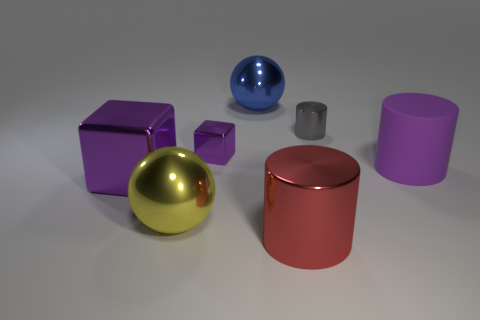Is the color of the large metallic cylinder the same as the rubber object?
Provide a short and direct response. No. There is a large yellow thing that is in front of the purple rubber thing; does it have the same shape as the small shiny object to the right of the big red thing?
Provide a short and direct response. No. There is another thing that is the same shape as the big yellow metallic object; what is it made of?
Provide a succinct answer. Metal. The thing that is both right of the big blue sphere and behind the tiny block is what color?
Your answer should be compact. Gray. Are there any large metallic balls that are in front of the purple block that is behind the purple metal block in front of the large purple rubber object?
Keep it short and to the point. Yes. What number of objects are either large red metallic cylinders or big purple shiny cubes?
Offer a terse response. 2. Does the gray thing have the same material as the ball that is behind the large yellow ball?
Your answer should be very brief. Yes. Is there any other thing that is the same color as the rubber cylinder?
Your answer should be very brief. Yes. How many things are purple cubes behind the rubber object or purple blocks in front of the rubber thing?
Keep it short and to the point. 2. What shape is the big metal object that is both on the right side of the yellow metallic object and behind the big red object?
Offer a terse response. Sphere. 